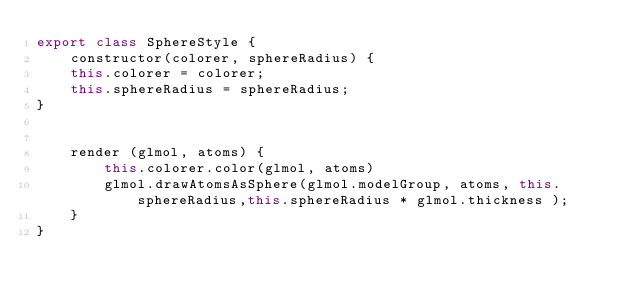<code> <loc_0><loc_0><loc_500><loc_500><_JavaScript_>export class SphereStyle { 
	constructor(colorer, sphereRadius) {
	this.colorer = colorer;
	this.sphereRadius = sphereRadius;
}


	render (glmol, atoms) {
		this.colorer.color(glmol, atoms)
		glmol.drawAtomsAsSphere(glmol.modelGroup, atoms, this.sphereRadius,this.sphereRadius * glmol.thickness );
	}
}

</code> 